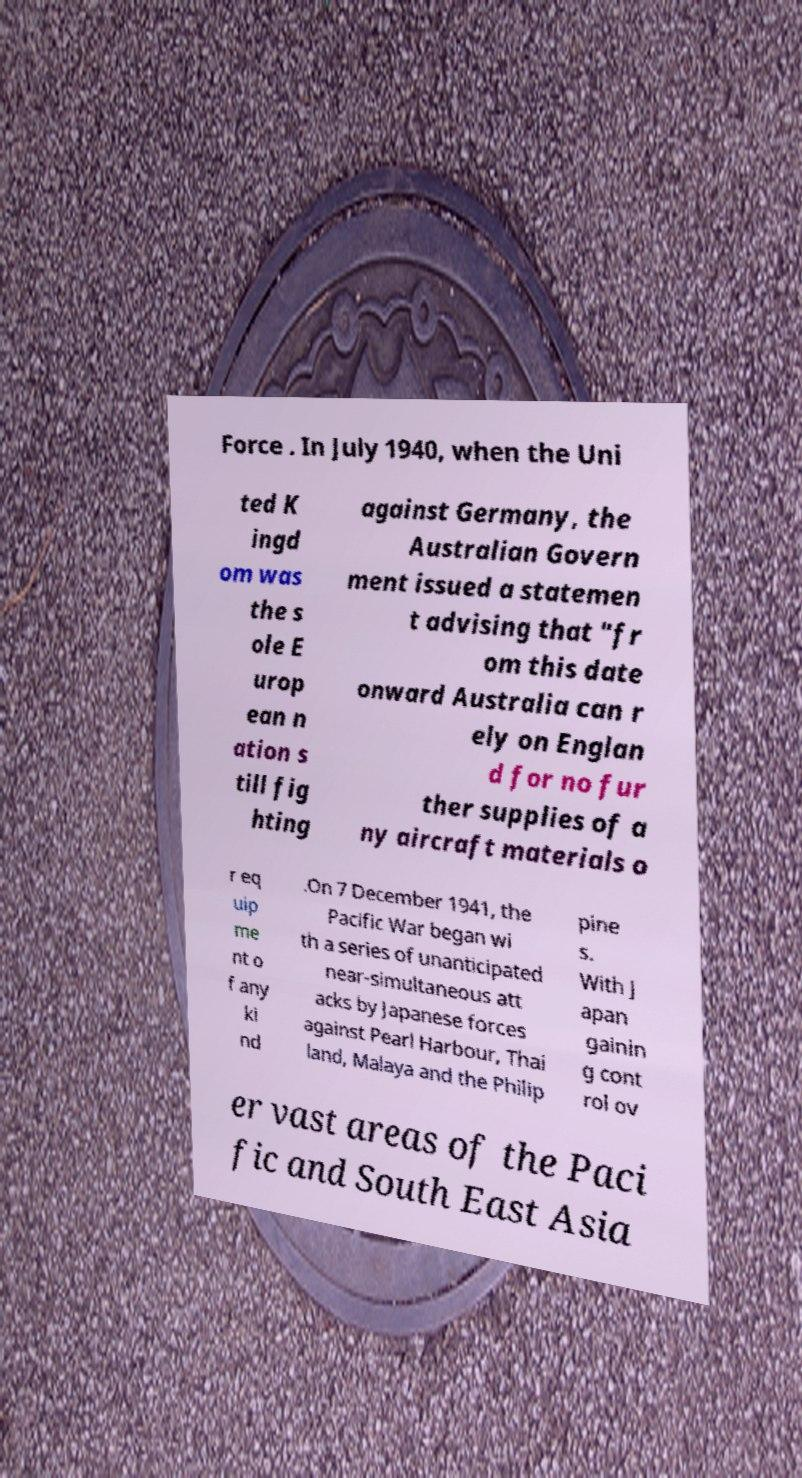For documentation purposes, I need the text within this image transcribed. Could you provide that? Force . In July 1940, when the Uni ted K ingd om was the s ole E urop ean n ation s till fig hting against Germany, the Australian Govern ment issued a statemen t advising that "fr om this date onward Australia can r ely on Englan d for no fur ther supplies of a ny aircraft materials o r eq uip me nt o f any ki nd .On 7 December 1941, the Pacific War began wi th a series of unanticipated near-simultaneous att acks by Japanese forces against Pearl Harbour, Thai land, Malaya and the Philip pine s. With J apan gainin g cont rol ov er vast areas of the Paci fic and South East Asia 